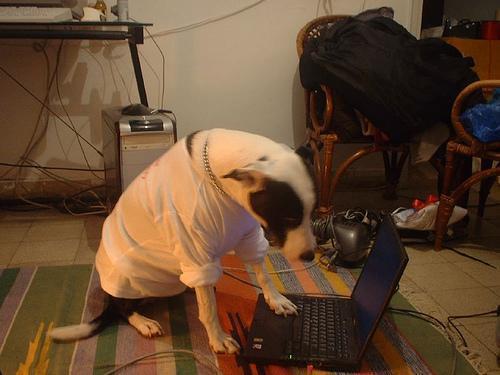What is the dog's paw resting on?
Indicate the correct response by choosing from the four available options to answer the question.
Options: Apple, keyboard, bone, cat. Keyboard. 